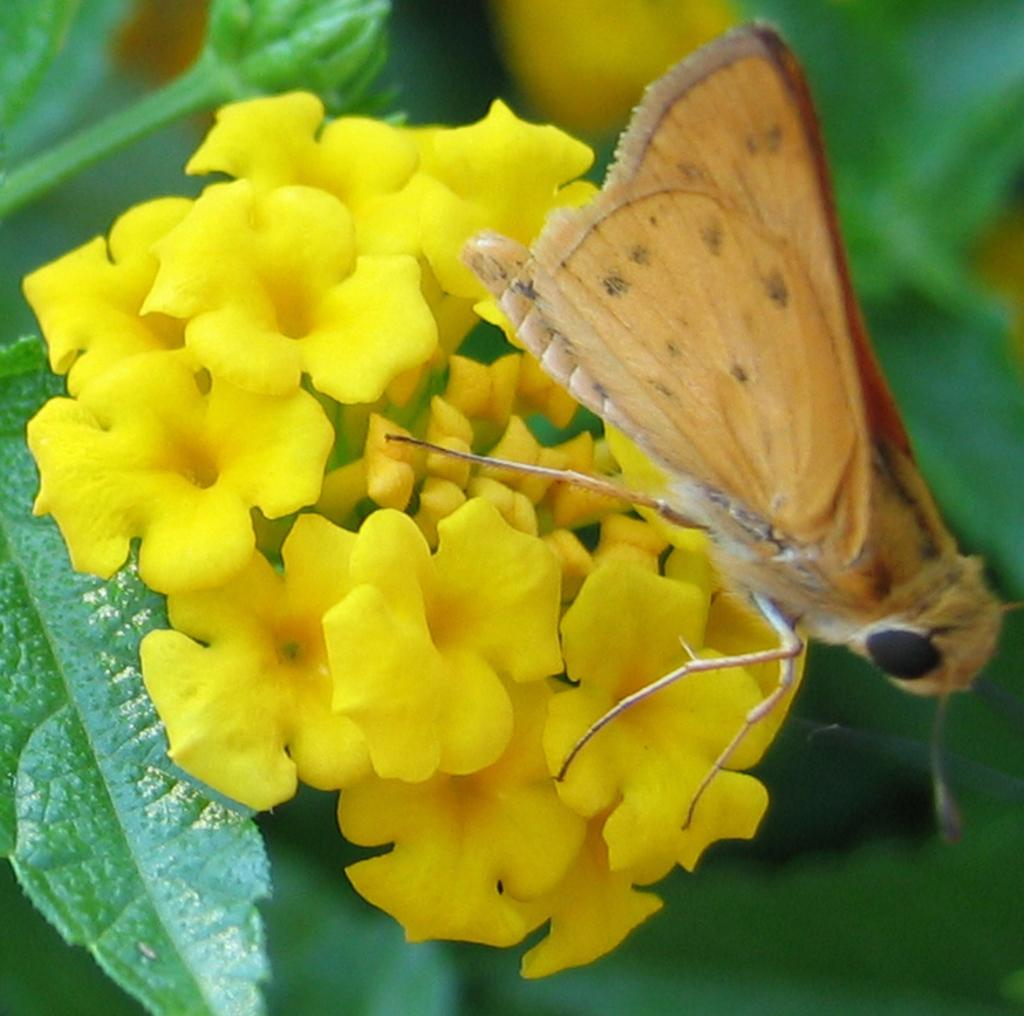What type of flowers can be seen in the image? There are yellow flowers in the image. What other plant-related object is visible in the image? There is a leaf in the image. Are there any animals or insects present in the image? Yes, there is a fly in the image. What historical event is being commemorated by the yellow flowers in the image? The yellow flowers in the image are not commemorating any historical event; they are simply flowers. 